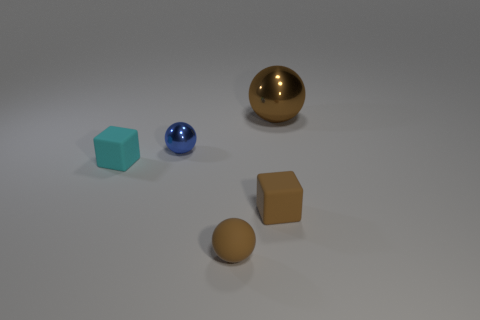Subtract all big balls. How many balls are left? 2 Add 2 small green cylinders. How many objects exist? 7 Subtract all brown spheres. How many spheres are left? 1 Add 3 tiny things. How many tiny things exist? 7 Subtract 0 yellow balls. How many objects are left? 5 Subtract all balls. How many objects are left? 2 Subtract all green blocks. Subtract all red cylinders. How many blocks are left? 2 Subtract all yellow cylinders. How many blue blocks are left? 0 Subtract all big green cylinders. Subtract all blue balls. How many objects are left? 4 Add 1 small metal spheres. How many small metal spheres are left? 2 